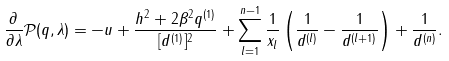Convert formula to latex. <formula><loc_0><loc_0><loc_500><loc_500>\frac { \partial } { \partial \lambda } \mathcal { P } ( q , \lambda ) = - u + \frac { h ^ { 2 } + 2 \beta ^ { 2 } q ^ { ( 1 ) } } { [ d ^ { ( 1 ) } ] ^ { 2 } } + \sum _ { l = 1 } ^ { n - 1 } \frac { 1 } { x _ { l } } \left ( \frac { 1 } { d ^ { ( l ) } } - \frac { 1 } { d ^ { ( l + 1 ) } } \right ) + \frac { 1 } { d ^ { ( n ) } } .</formula> 